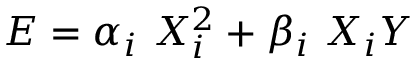Convert formula to latex. <formula><loc_0><loc_0><loc_500><loc_500>E = \alpha _ { i } \, X _ { i } ^ { 2 } + \beta _ { i } \, X _ { i } Y</formula> 